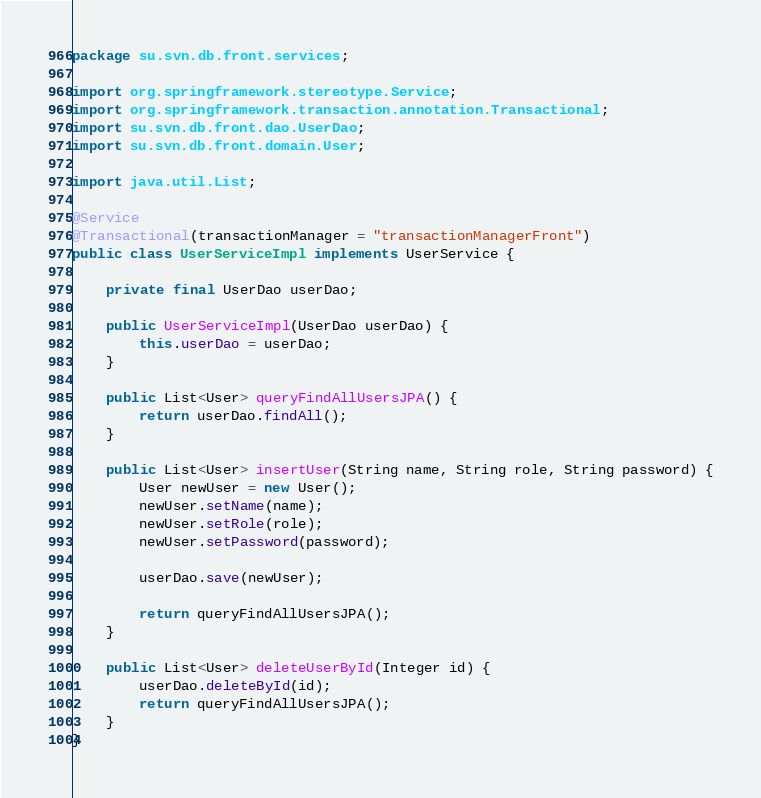Convert code to text. <code><loc_0><loc_0><loc_500><loc_500><_Java_>package su.svn.db.front.services;

import org.springframework.stereotype.Service;
import org.springframework.transaction.annotation.Transactional;
import su.svn.db.front.dao.UserDao;
import su.svn.db.front.domain.User;

import java.util.List;

@Service
@Transactional(transactionManager = "transactionManagerFront")
public class UserServiceImpl implements UserService {

    private final UserDao userDao;

    public UserServiceImpl(UserDao userDao) {
        this.userDao = userDao;
    }

    public List<User> queryFindAllUsersJPA() {
        return userDao.findAll();
    }

    public List<User> insertUser(String name, String role, String password) {
        User newUser = new User();
        newUser.setName(name);
        newUser.setRole(role);
        newUser.setPassword(password);

        userDao.save(newUser);

        return queryFindAllUsersJPA();
    }

    public List<User> deleteUserById(Integer id) {
        userDao.deleteById(id);
        return queryFindAllUsersJPA();
    }
}
</code> 